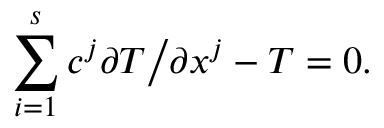<formula> <loc_0><loc_0><loc_500><loc_500>\sum _ { i = 1 } ^ { s } c ^ { j } \partial T \Big / \partial x ^ { j } - T = 0 .</formula> 